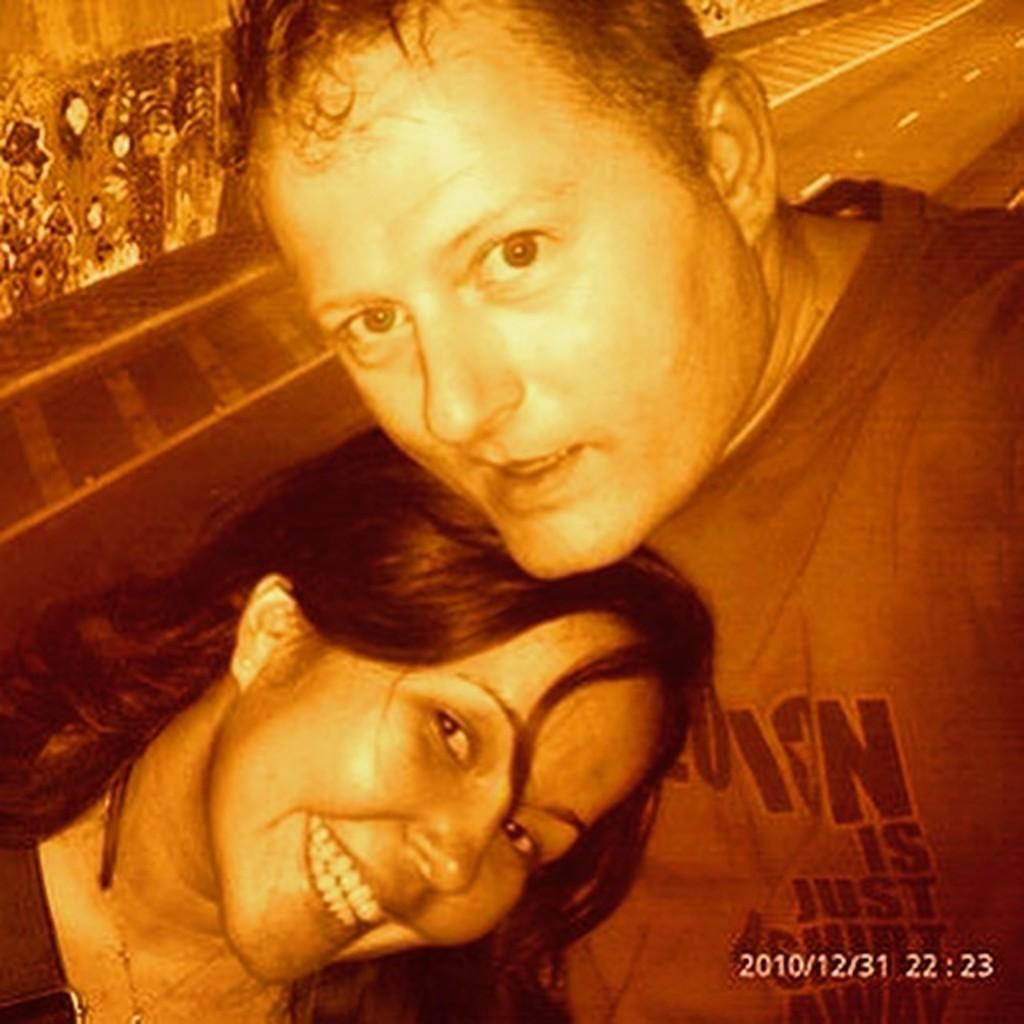How would you summarize this image in a sentence or two? In this image in the front there are persons smiling. 